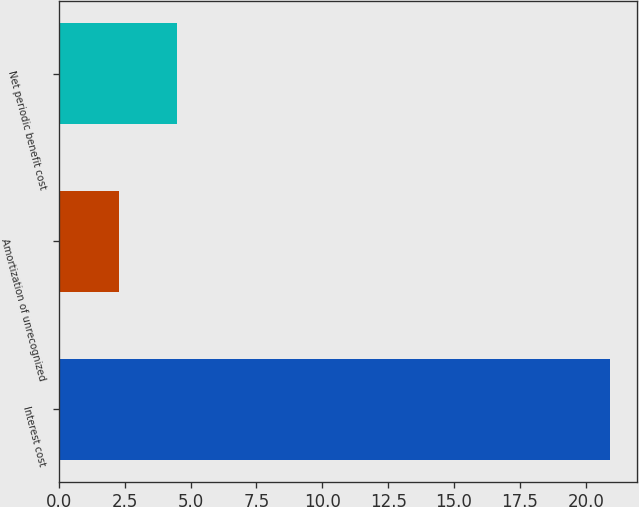Convert chart to OTSL. <chart><loc_0><loc_0><loc_500><loc_500><bar_chart><fcel>Interest cost<fcel>Amortization of unrecognized<fcel>Net periodic benefit cost<nl><fcel>20.9<fcel>2.3<fcel>4.5<nl></chart> 